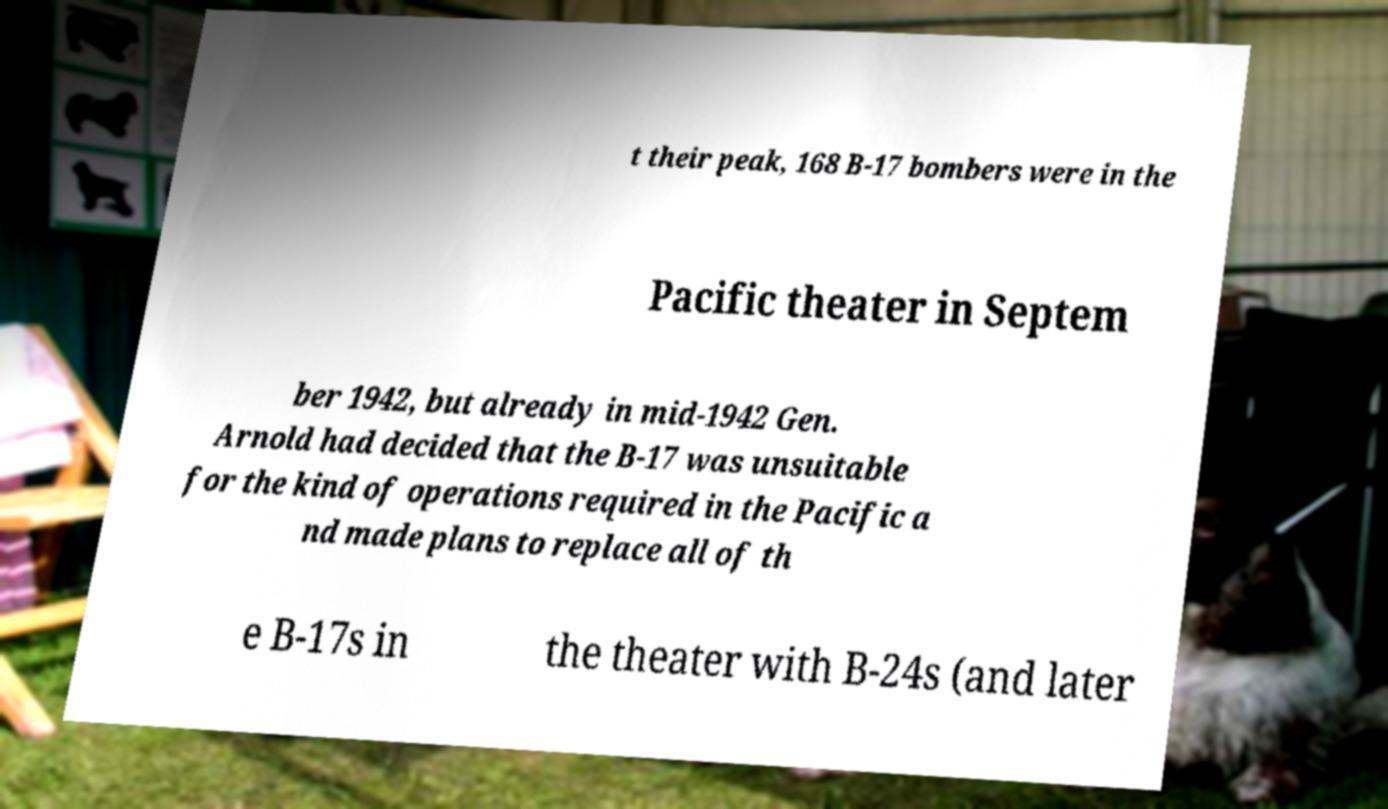For documentation purposes, I need the text within this image transcribed. Could you provide that? t their peak, 168 B-17 bombers were in the Pacific theater in Septem ber 1942, but already in mid-1942 Gen. Arnold had decided that the B-17 was unsuitable for the kind of operations required in the Pacific a nd made plans to replace all of th e B-17s in the theater with B-24s (and later 